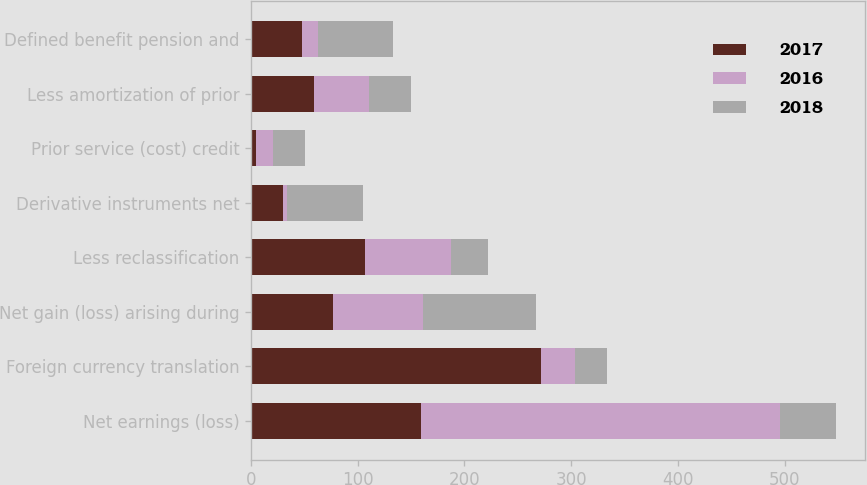<chart> <loc_0><loc_0><loc_500><loc_500><stacked_bar_chart><ecel><fcel>Net earnings (loss)<fcel>Foreign currency translation<fcel>Net gain (loss) arising during<fcel>Less reclassification<fcel>Derivative instruments net<fcel>Prior service (cost) credit<fcel>Less amortization of prior<fcel>Defined benefit pension and<nl><fcel>2017<fcel>159<fcel>272<fcel>77<fcel>107<fcel>30<fcel>5<fcel>59<fcel>48<nl><fcel>2016<fcel>337<fcel>32<fcel>84<fcel>80<fcel>4<fcel>16<fcel>52<fcel>15<nl><fcel>2018<fcel>52<fcel>30<fcel>106<fcel>35<fcel>71<fcel>30<fcel>39<fcel>70<nl></chart> 